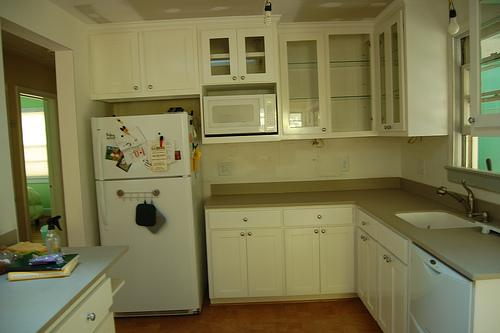Can you enumerate the types of kitchen appliances and items present in the image?  A silver faucet, white sink, window, dishwasher, electrical outlet, white fridge, white microwave, clear plastic bottle, yellow and white book, red magnet, white paper, light bulb, light switch, and kitchen drawers. Examine the interactions amongst the objects in the image and describe the purpose of the hanging energy saver light bulb. The hanging energy saver light bulb is providing light to the kitchen, especially over the sink area, where tasks such as dishwashing are done. What is attached to the fridge in the image? A red magnet and papers are attached to the fridge. How many kitchen drawers can be seen in this image? There are 8 kitchen drawers visible in the image. Assess the image quality in terms of brightness and clarity of the objects. The image quality is good with clear visibility of objects and appropriate brightness. Provide the sentiment elicited by examining this image. The image evokes a feeling of neatness and organization in a modern kitchen. Which object in the image is used for cleaning the kitchen? A clear spray bottle with a black nozzle is for cleaning. Determine the reasoning behind why the small white fridge has magnets and papers hung on it. The small white fridge serves as a convenient central location to hold important reminders, photos, or papers using magnets, making it easily accessible and visible in the kitchen. Provide a short caption describing the overall scene of this kitchen image. A clean and organized kitchen with various appliances, drawers, and some small items on countertops. Which type of light bulb is seen dangling above the sink?  An energy saver light bulb is hanging above the sink. Is the orange dishwasher near the sink on the left side? There's no orange dishwasher in the image, it is white. Is there a brown electrical outlet next to the grey fridge? There is no brown electrical outlet or grey fridge in the image. The electrical outlet is white, and it is next to a white fridge. Are there any green kitchen drawers in the bottom row? There are no green kitchen drawers in the image, only white lower cabinets with silver knobs. Does the kitchen have a purple ceiling with a white paint spot on it? The kitchen does not have a purple ceiling, and the white paint spot is actually on the white ceiling. Can you see a pink paper attached to the freezer with a blue magnet? No, there is no pink paper, and the magnet on the fridge is red. The paper on the fridge is white. Can you find a blue microwave next to a black fridge? There is no blue microwave or black fridge. The microwave is white, and the fridge is also white. 